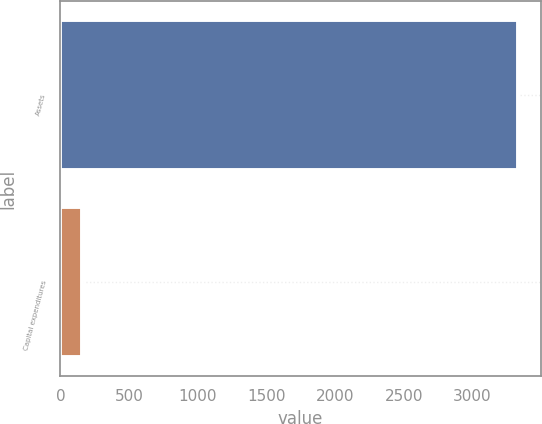<chart> <loc_0><loc_0><loc_500><loc_500><bar_chart><fcel>Assets<fcel>Capital expenditures<nl><fcel>3332<fcel>154<nl></chart> 